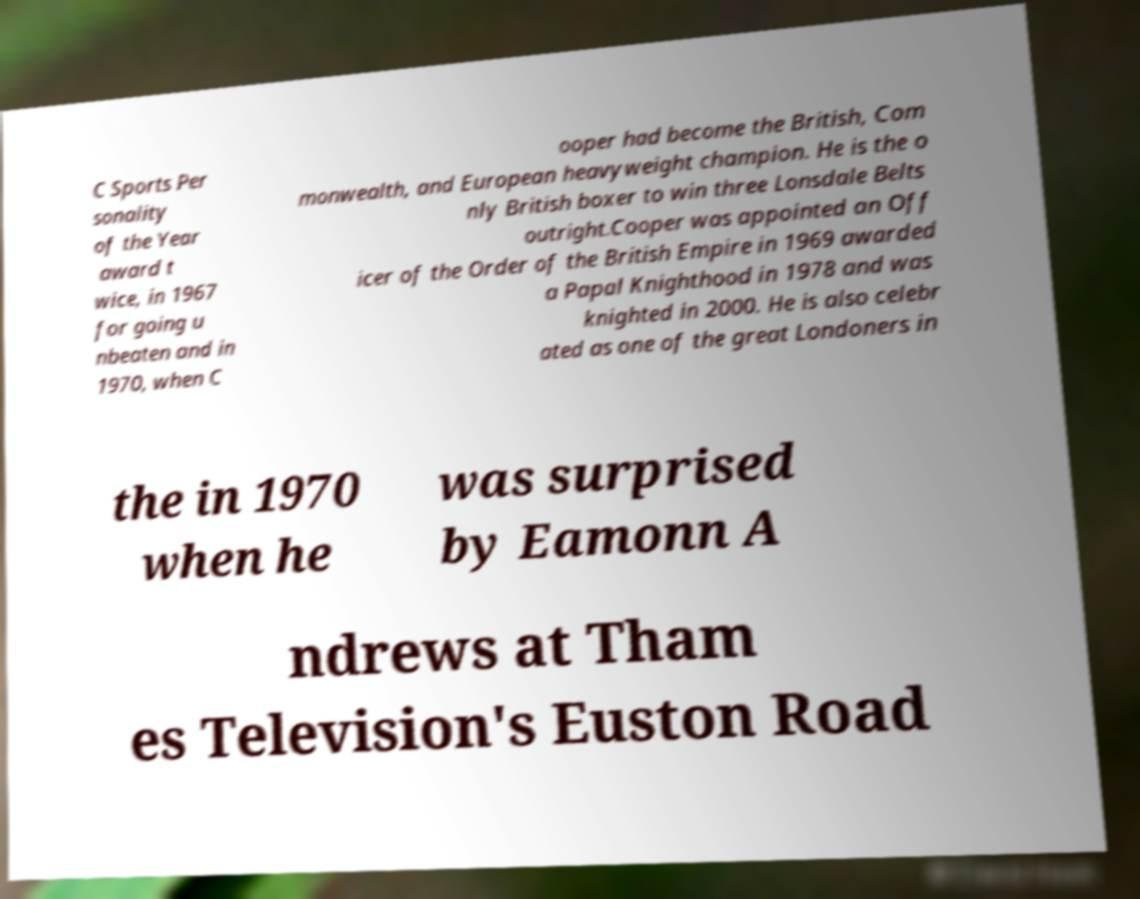Could you assist in decoding the text presented in this image and type it out clearly? C Sports Per sonality of the Year award t wice, in 1967 for going u nbeaten and in 1970, when C ooper had become the British, Com monwealth, and European heavyweight champion. He is the o nly British boxer to win three Lonsdale Belts outright.Cooper was appointed an Off icer of the Order of the British Empire in 1969 awarded a Papal Knighthood in 1978 and was knighted in 2000. He is also celebr ated as one of the great Londoners in the in 1970 when he was surprised by Eamonn A ndrews at Tham es Television's Euston Road 